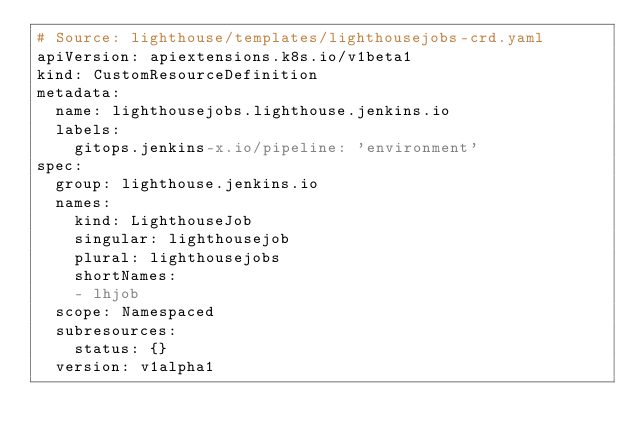<code> <loc_0><loc_0><loc_500><loc_500><_YAML_># Source: lighthouse/templates/lighthousejobs-crd.yaml
apiVersion: apiextensions.k8s.io/v1beta1
kind: CustomResourceDefinition
metadata:
  name: lighthousejobs.lighthouse.jenkins.io
  labels:
    gitops.jenkins-x.io/pipeline: 'environment'
spec:
  group: lighthouse.jenkins.io
  names:
    kind: LighthouseJob
    singular: lighthousejob
    plural: lighthousejobs
    shortNames:
    - lhjob
  scope: Namespaced
  subresources:
    status: {}
  version: v1alpha1
</code> 